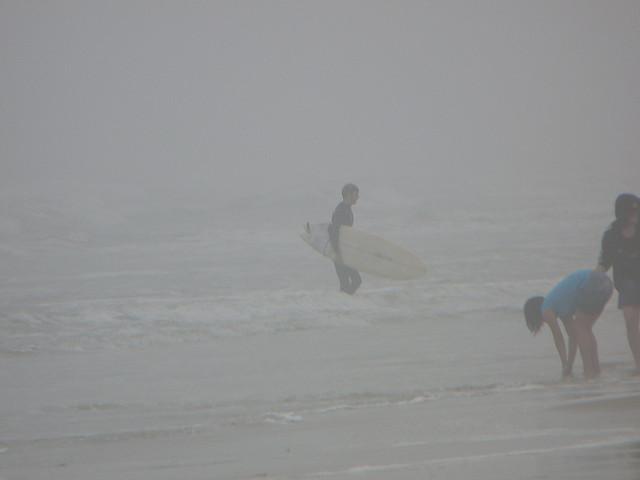Is this a blizzard?
Answer briefly. No. Are the people having fun on the beach?
Be succinct. Yes. How many people?
Write a very short answer. 3. What is this person holding?
Answer briefly. Surfboard. Is it raining?
Short answer required. No. What is rolling in from the ocean?
Keep it brief. Waves. What is the weather like?
Concise answer only. Foggy. What is the boy walking on?
Give a very brief answer. Beach. Are there waves?
Answer briefly. Yes. Why is the background blurry?
Give a very brief answer. Foggy. Why is the man walking in the snow with a surfboard?
Quick response, please. Not snow. How can you tell the water will be cold?
Be succinct. Clouds. What sport is the person performing?
Give a very brief answer. Surfing. 